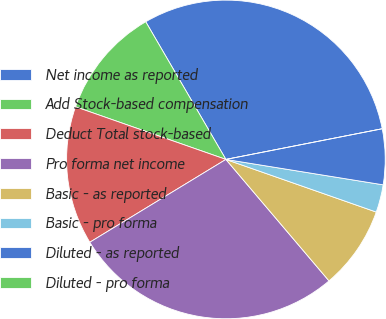<chart> <loc_0><loc_0><loc_500><loc_500><pie_chart><fcel>Net income as reported<fcel>Add Stock-based compensation<fcel>Deduct Total stock-based<fcel>Pro forma net income<fcel>Basic - as reported<fcel>Basic - pro forma<fcel>Diluted - as reported<fcel>Diluted - pro forma<nl><fcel>30.31%<fcel>11.25%<fcel>14.06%<fcel>27.5%<fcel>8.44%<fcel>2.81%<fcel>5.63%<fcel>0.0%<nl></chart> 